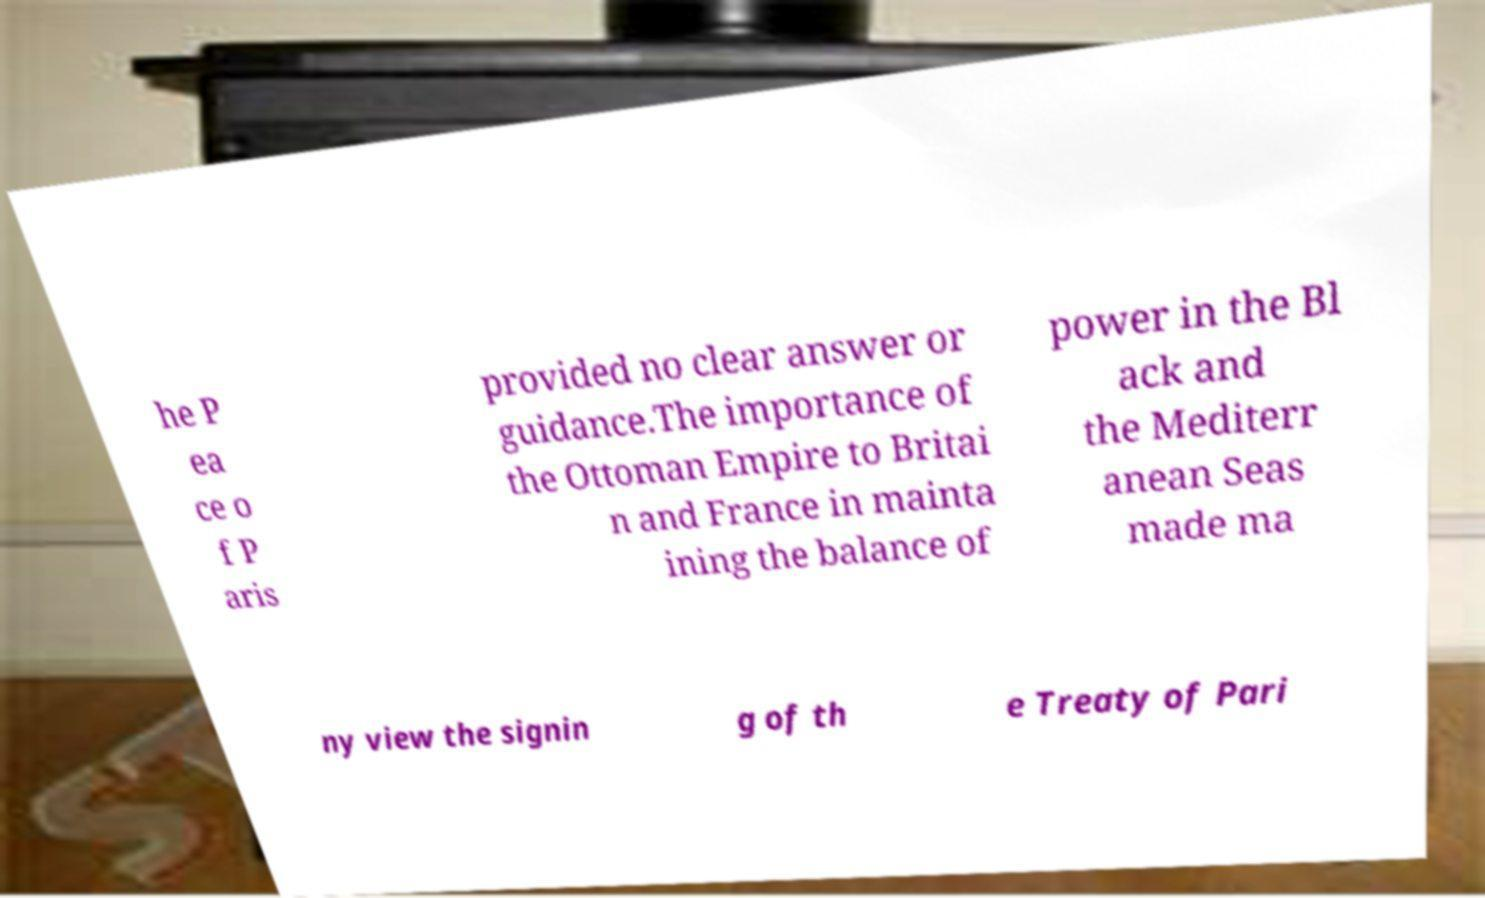Please identify and transcribe the text found in this image. he P ea ce o f P aris provided no clear answer or guidance.The importance of the Ottoman Empire to Britai n and France in mainta ining the balance of power in the Bl ack and the Mediterr anean Seas made ma ny view the signin g of th e Treaty of Pari 